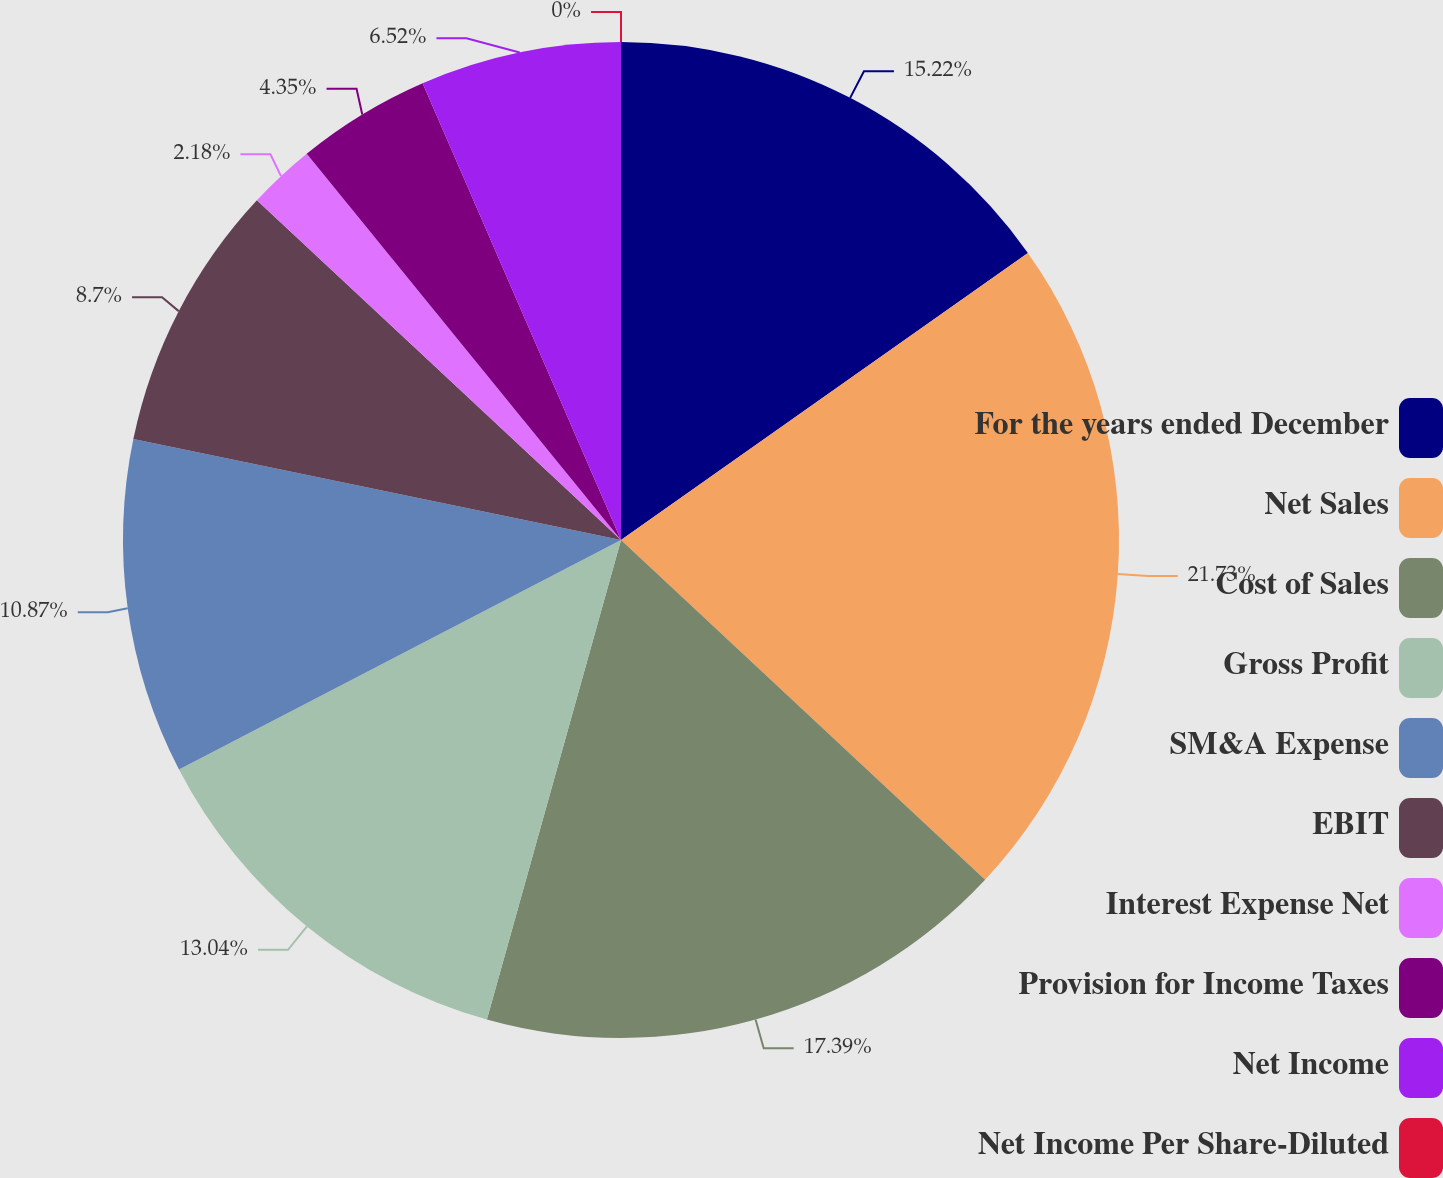Convert chart to OTSL. <chart><loc_0><loc_0><loc_500><loc_500><pie_chart><fcel>For the years ended December<fcel>Net Sales<fcel>Cost of Sales<fcel>Gross Profit<fcel>SM&A Expense<fcel>EBIT<fcel>Interest Expense Net<fcel>Provision for Income Taxes<fcel>Net Income<fcel>Net Income Per Share-Diluted<nl><fcel>15.22%<fcel>21.73%<fcel>17.39%<fcel>13.04%<fcel>10.87%<fcel>8.7%<fcel>2.18%<fcel>4.35%<fcel>6.52%<fcel>0.0%<nl></chart> 